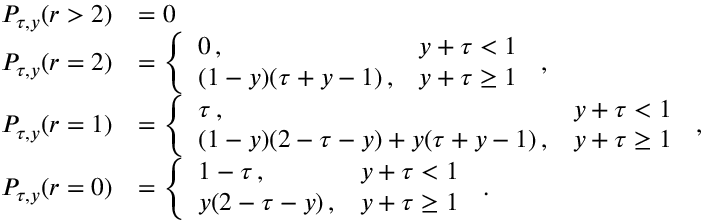<formula> <loc_0><loc_0><loc_500><loc_500>\begin{array} { r l } { P _ { \tau , y } ( r > 2 ) } & { = 0 } \\ { P _ { \tau , y } ( r = 2 ) } & { = \left \{ \begin{array} { l l } { 0 \, , } & { y + \tau < 1 } \\ { ( 1 - y ) ( \tau + y - 1 ) \, , } & { y + \tau \geq 1 } \end{array} \, , } \\ { P _ { \tau , y } ( r = 1 ) } & { = \left \{ \begin{array} { l l } { \tau \, , } & { y + \tau < 1 } \\ { ( 1 - y ) ( 2 - \tau - y ) + y ( \tau + y - 1 ) \, , } & { y + \tau \geq 1 } \end{array} \, , } \\ { P _ { \tau , y } ( r = 0 ) } & { = \left \{ \begin{array} { l l } { 1 - \tau \, , } & { y + \tau < 1 } \\ { y ( 2 - \tau - y ) \, , } & { y + \tau \geq 1 } \end{array} \, . } \end{array}</formula> 